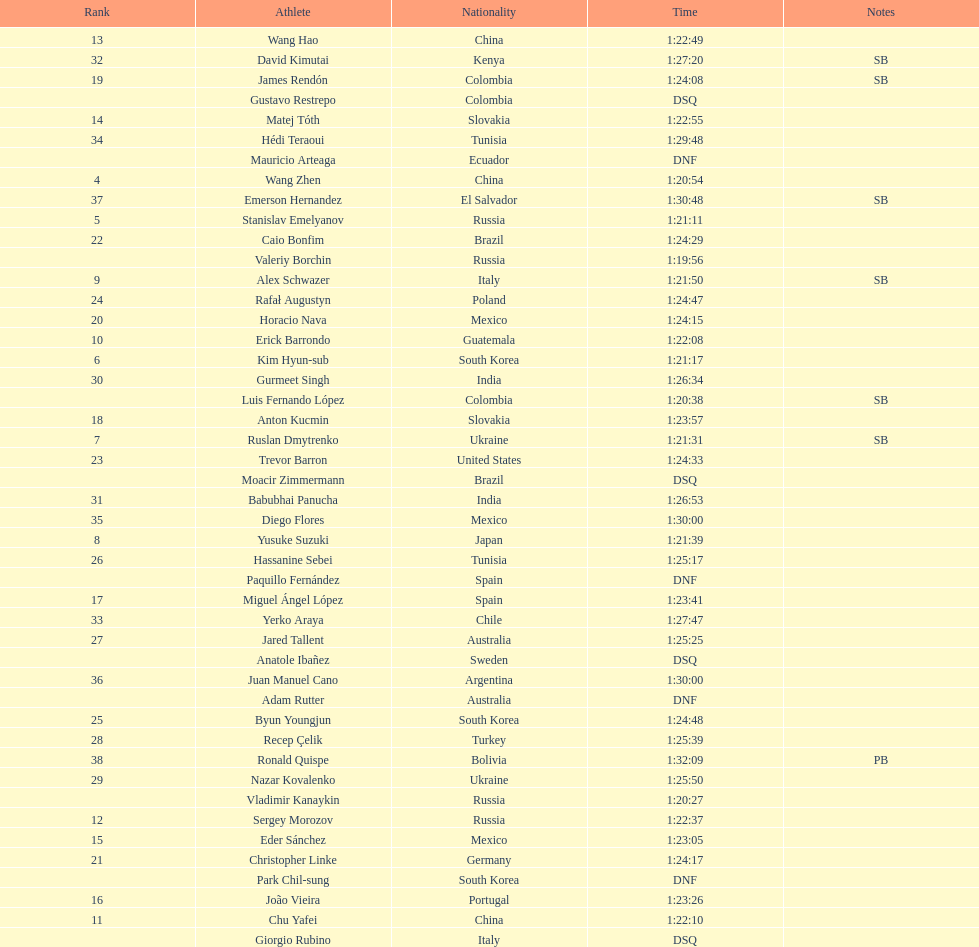Give me the full table as a dictionary. {'header': ['Rank', 'Athlete', 'Nationality', 'Time', 'Notes'], 'rows': [['13', 'Wang Hao', 'China', '1:22:49', ''], ['32', 'David Kimutai', 'Kenya', '1:27:20', 'SB'], ['19', 'James Rendón', 'Colombia', '1:24:08', 'SB'], ['', 'Gustavo Restrepo', 'Colombia', 'DSQ', ''], ['14', 'Matej Tóth', 'Slovakia', '1:22:55', ''], ['34', 'Hédi Teraoui', 'Tunisia', '1:29:48', ''], ['', 'Mauricio Arteaga', 'Ecuador', 'DNF', ''], ['4', 'Wang Zhen', 'China', '1:20:54', ''], ['37', 'Emerson Hernandez', 'El Salvador', '1:30:48', 'SB'], ['5', 'Stanislav Emelyanov', 'Russia', '1:21:11', ''], ['22', 'Caio Bonfim', 'Brazil', '1:24:29', ''], ['', 'Valeriy Borchin', 'Russia', '1:19:56', ''], ['9', 'Alex Schwazer', 'Italy', '1:21:50', 'SB'], ['24', 'Rafał Augustyn', 'Poland', '1:24:47', ''], ['20', 'Horacio Nava', 'Mexico', '1:24:15', ''], ['10', 'Erick Barrondo', 'Guatemala', '1:22:08', ''], ['6', 'Kim Hyun-sub', 'South Korea', '1:21:17', ''], ['30', 'Gurmeet Singh', 'India', '1:26:34', ''], ['', 'Luis Fernando López', 'Colombia', '1:20:38', 'SB'], ['18', 'Anton Kucmin', 'Slovakia', '1:23:57', ''], ['7', 'Ruslan Dmytrenko', 'Ukraine', '1:21:31', 'SB'], ['23', 'Trevor Barron', 'United States', '1:24:33', ''], ['', 'Moacir Zimmermann', 'Brazil', 'DSQ', ''], ['31', 'Babubhai Panucha', 'India', '1:26:53', ''], ['35', 'Diego Flores', 'Mexico', '1:30:00', ''], ['8', 'Yusuke Suzuki', 'Japan', '1:21:39', ''], ['26', 'Hassanine Sebei', 'Tunisia', '1:25:17', ''], ['', 'Paquillo Fernández', 'Spain', 'DNF', ''], ['17', 'Miguel Ángel López', 'Spain', '1:23:41', ''], ['33', 'Yerko Araya', 'Chile', '1:27:47', ''], ['27', 'Jared Tallent', 'Australia', '1:25:25', ''], ['', 'Anatole Ibañez', 'Sweden', 'DSQ', ''], ['36', 'Juan Manuel Cano', 'Argentina', '1:30:00', ''], ['', 'Adam Rutter', 'Australia', 'DNF', ''], ['25', 'Byun Youngjun', 'South Korea', '1:24:48', ''], ['28', 'Recep Çelik', 'Turkey', '1:25:39', ''], ['38', 'Ronald Quispe', 'Bolivia', '1:32:09', 'PB'], ['29', 'Nazar Kovalenko', 'Ukraine', '1:25:50', ''], ['', 'Vladimir Kanaykin', 'Russia', '1:20:27', ''], ['12', 'Sergey Morozov', 'Russia', '1:22:37', ''], ['15', 'Eder Sánchez', 'Mexico', '1:23:05', ''], ['21', 'Christopher Linke', 'Germany', '1:24:17', ''], ['', 'Park Chil-sung', 'South Korea', 'DNF', ''], ['16', 'João Vieira', 'Portugal', '1:23:26', ''], ['11', 'Chu Yafei', 'China', '1:22:10', ''], ['', 'Giorgio Rubino', 'Italy', 'DSQ', '']]} Which competitor was ranked first? Valeriy Borchin. 